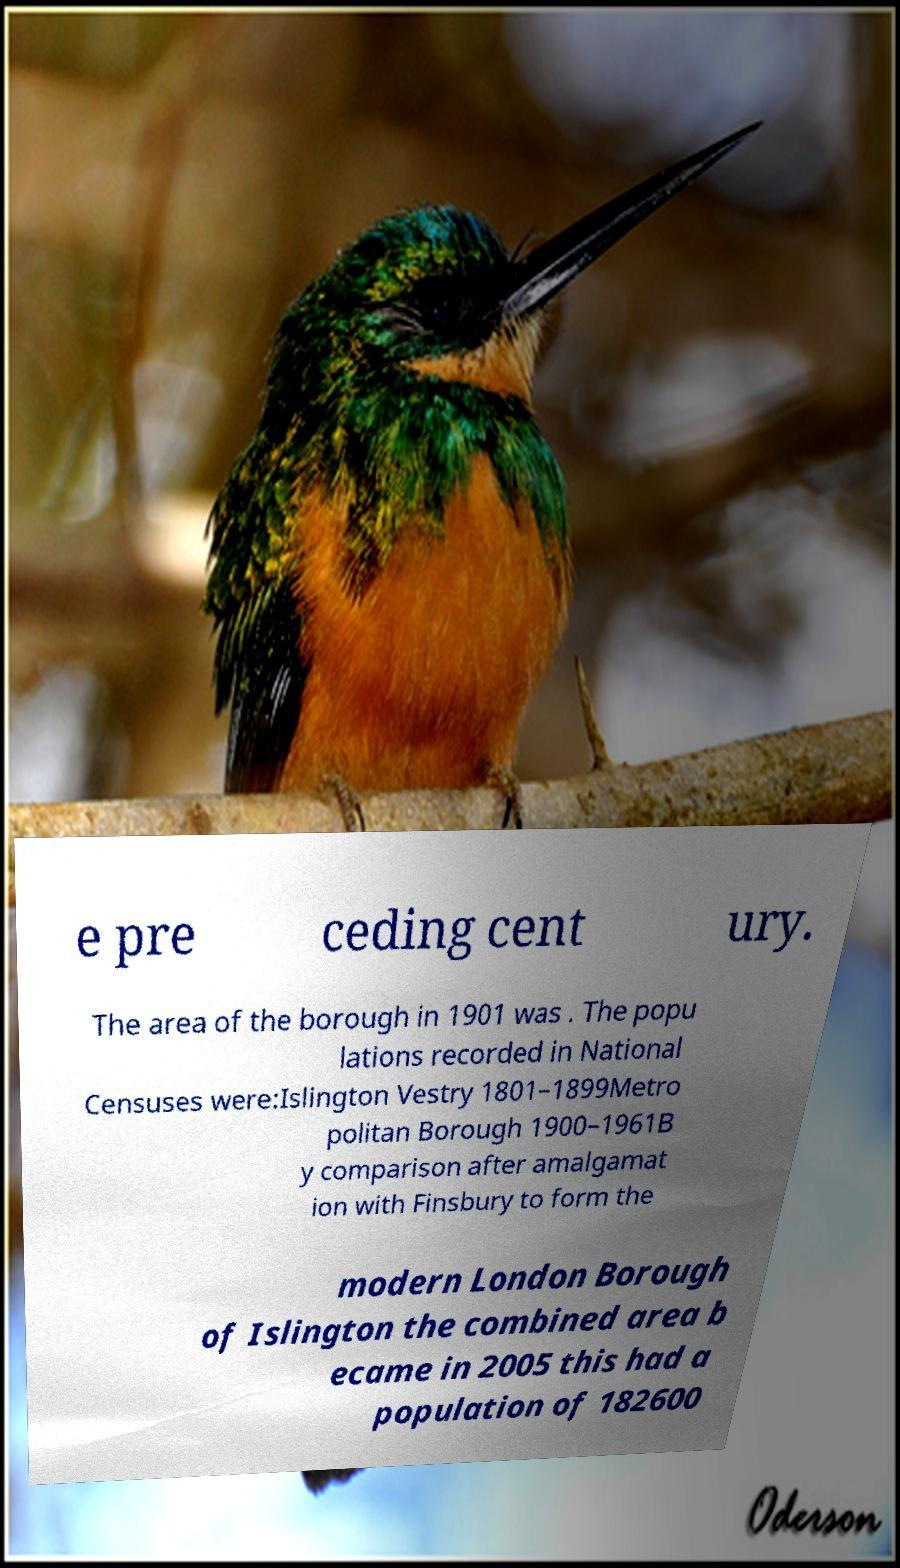Could you extract and type out the text from this image? e pre ceding cent ury. The area of the borough in 1901 was . The popu lations recorded in National Censuses were:Islington Vestry 1801–1899Metro politan Borough 1900–1961B y comparison after amalgamat ion with Finsbury to form the modern London Borough of Islington the combined area b ecame in 2005 this had a population of 182600 